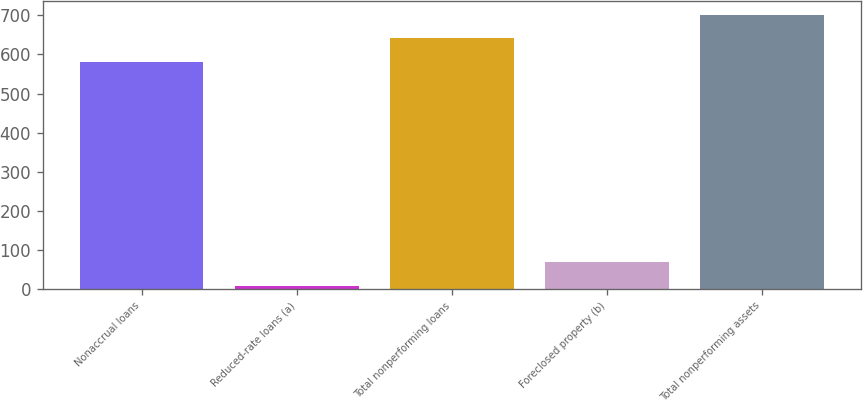Convert chart to OTSL. <chart><loc_0><loc_0><loc_500><loc_500><bar_chart><fcel>Nonaccrual loans<fcel>Reduced-rate loans (a)<fcel>Total nonperforming loans<fcel>Foreclosed property (b)<fcel>Total nonperforming assets<nl><fcel>582<fcel>8<fcel>641.9<fcel>67.9<fcel>701.8<nl></chart> 